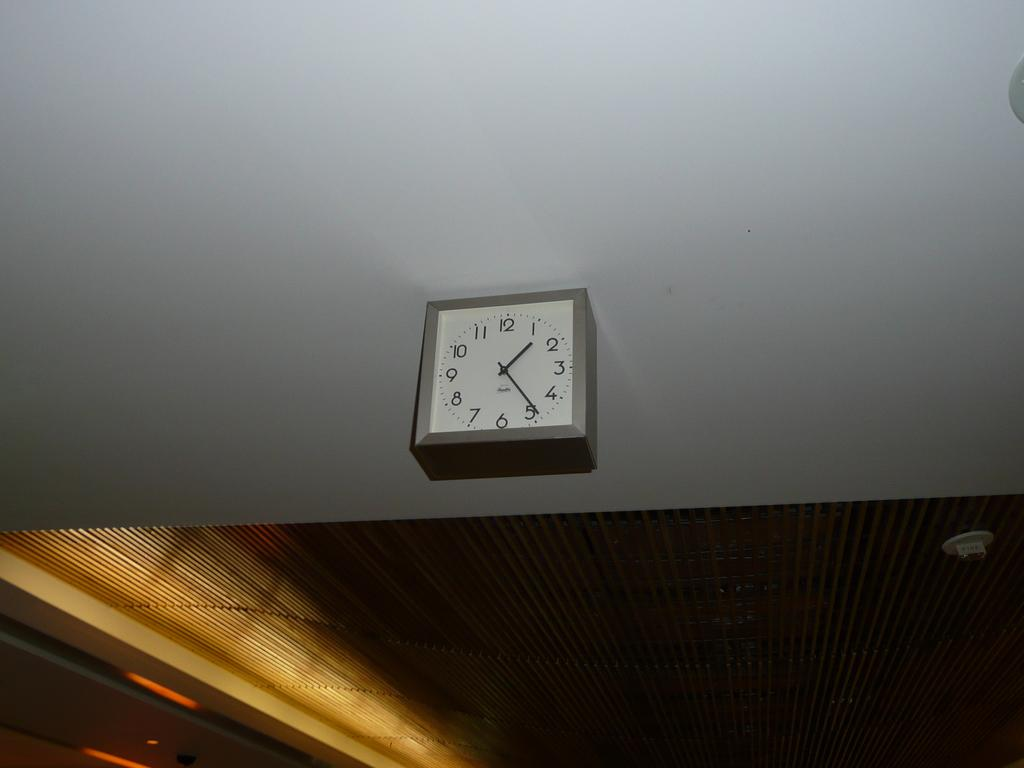<image>
Offer a succinct explanation of the picture presented. A clock on a ceiling shows the time is 1:25. 